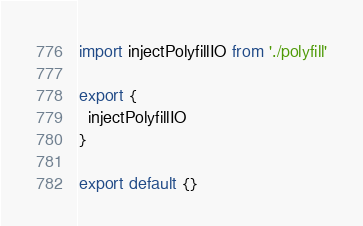Convert code to text. <code><loc_0><loc_0><loc_500><loc_500><_JavaScript_>import injectPolyfillIO from './polyfill'

export {
  injectPolyfillIO
}

export default {}
</code> 